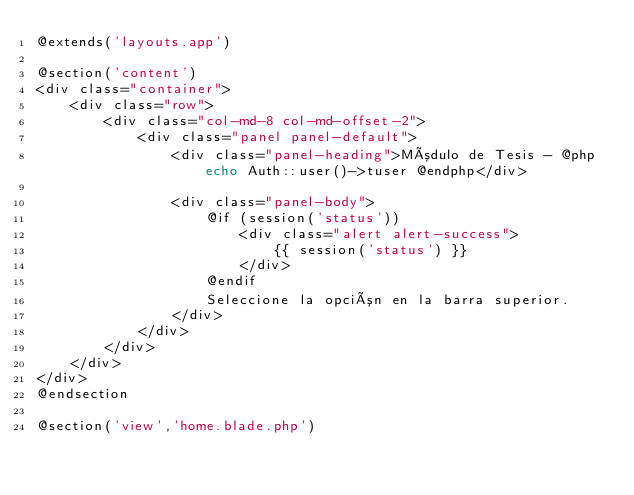Convert code to text. <code><loc_0><loc_0><loc_500><loc_500><_PHP_>@extends('layouts.app')

@section('content')
<div class="container">
    <div class="row">
        <div class="col-md-8 col-md-offset-2">
            <div class="panel panel-default">
                <div class="panel-heading">Módulo de Tesis - @php echo Auth::user()->tuser @endphp</div>

                <div class="panel-body">
                    @if (session('status'))
                        <div class="alert alert-success">
                            {{ session('status') }}
                        </div>
                    @endif
                    Seleccione la opción en la barra superior.
                </div>
            </div>
        </div>
    </div>
</div>
@endsection

@section('view','home.blade.php')</code> 